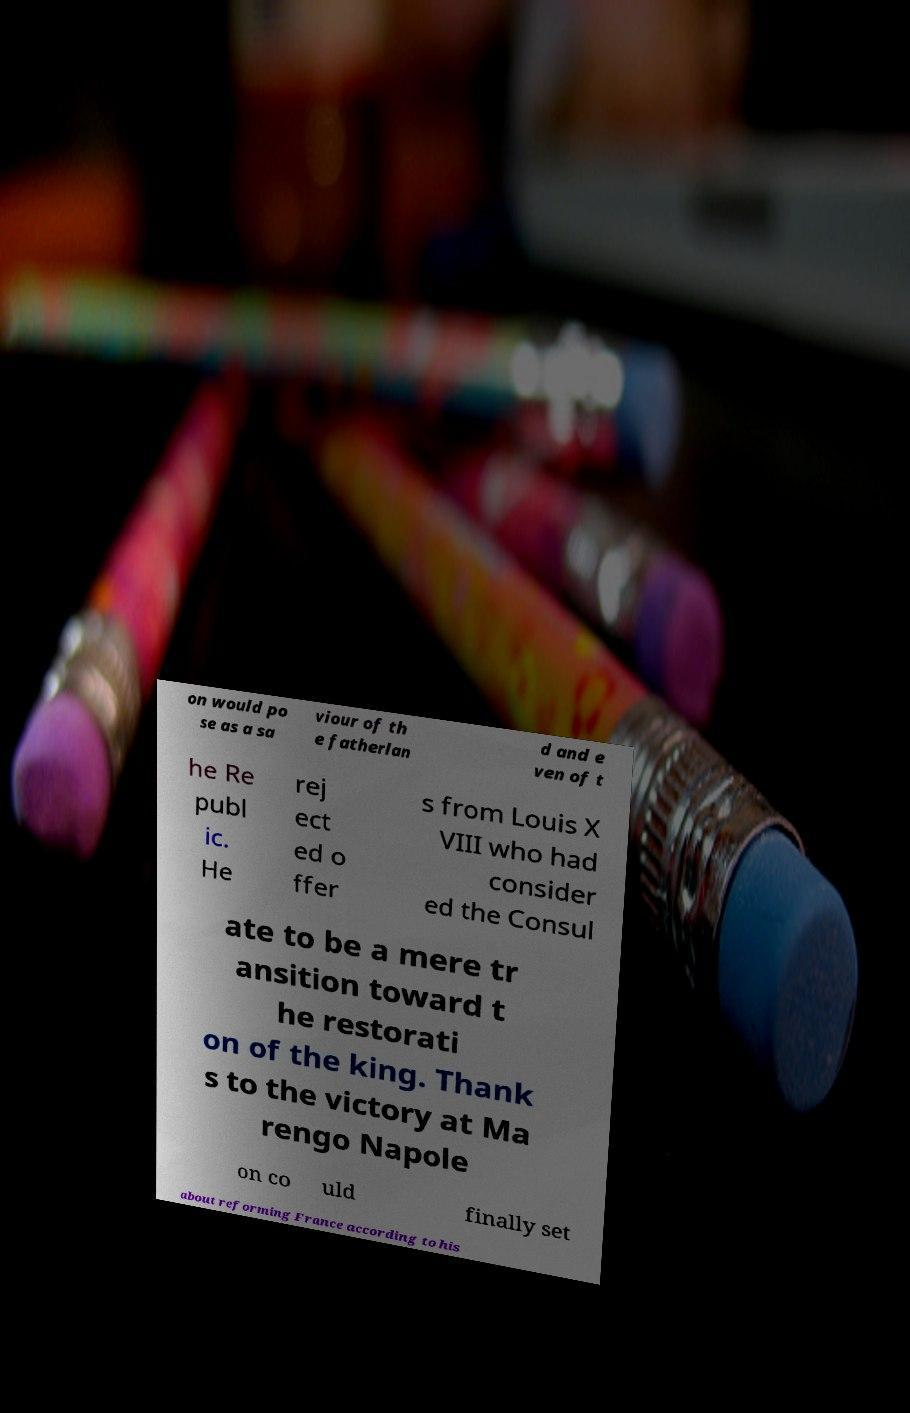I need the written content from this picture converted into text. Can you do that? on would po se as a sa viour of th e fatherlan d and e ven of t he Re publ ic. He rej ect ed o ffer s from Louis X VIII who had consider ed the Consul ate to be a mere tr ansition toward t he restorati on of the king. Thank s to the victory at Ma rengo Napole on co uld finally set about reforming France according to his 